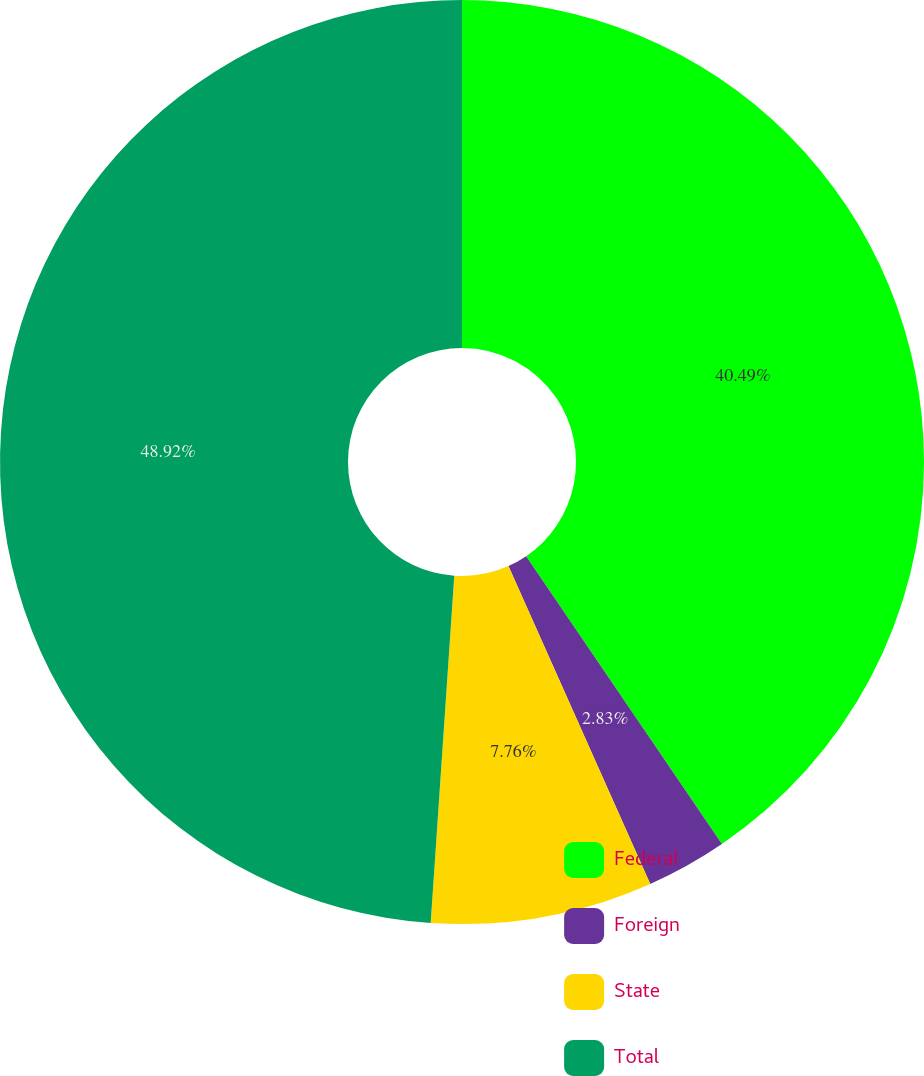<chart> <loc_0><loc_0><loc_500><loc_500><pie_chart><fcel>Federal<fcel>Foreign<fcel>State<fcel>Total<nl><fcel>40.49%<fcel>2.83%<fcel>7.76%<fcel>48.92%<nl></chart> 